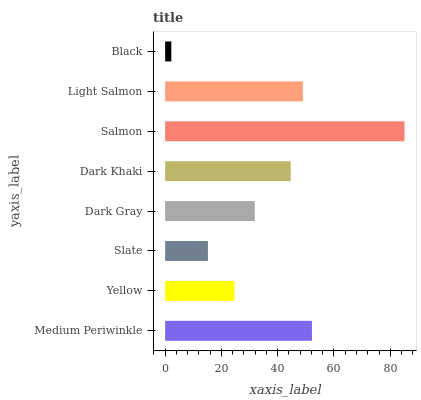Is Black the minimum?
Answer yes or no. Yes. Is Salmon the maximum?
Answer yes or no. Yes. Is Yellow the minimum?
Answer yes or no. No. Is Yellow the maximum?
Answer yes or no. No. Is Medium Periwinkle greater than Yellow?
Answer yes or no. Yes. Is Yellow less than Medium Periwinkle?
Answer yes or no. Yes. Is Yellow greater than Medium Periwinkle?
Answer yes or no. No. Is Medium Periwinkle less than Yellow?
Answer yes or no. No. Is Dark Khaki the high median?
Answer yes or no. Yes. Is Dark Gray the low median?
Answer yes or no. Yes. Is Dark Gray the high median?
Answer yes or no. No. Is Salmon the low median?
Answer yes or no. No. 